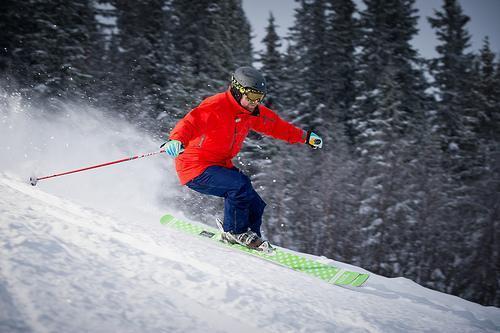How many people are in the photo?
Give a very brief answer. 1. 